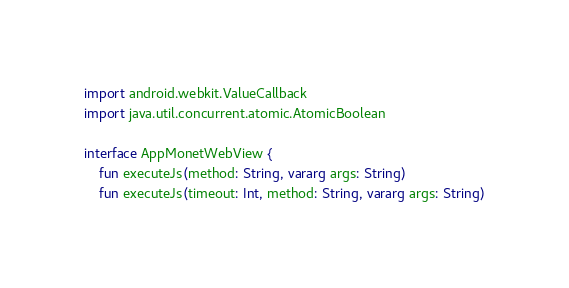Convert code to text. <code><loc_0><loc_0><loc_500><loc_500><_Kotlin_>import android.webkit.ValueCallback
import java.util.concurrent.atomic.AtomicBoolean

interface AppMonetWebView {
    fun executeJs(method: String, vararg args: String)
    fun executeJs(timeout: Int, method: String, vararg args: String)</code> 